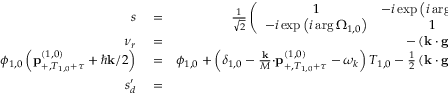Convert formula to latex. <formula><loc_0><loc_0><loc_500><loc_500>\begin{array} { r l r } { s } & = } & { \frac { 1 } { \sqrt { 2 } } \left ( \begin{array} { c c } { 1 } & { - i \exp \left ( i \arg \Omega _ { 1 , 0 } \right ) } \\ { - i \exp \left ( i \arg \Omega _ { 1 , 0 } \right ) } & { 1 } \end{array} \right ) , } \\ { \nu _ { r } } & = } & { - \left ( k \cdot g - \alpha \right ) T _ { 1 , 0 } , } \\ { \phi _ { 1 , 0 } \left ( p _ { + , T _ { 1 , 0 } + \tau } ^ { \left ( 1 , 0 \right ) } + \hbar { k } / 2 \right ) } & = } & { \phi _ { 1 , 0 } + \left ( \delta _ { 1 , 0 } - \frac { k } { M } \cdot p _ { + , T _ { 1 , 0 } + \tau } ^ { \left ( 1 , 0 \right ) } - \omega _ { k } \right ) T _ { 1 , 0 } - \frac { 1 } { 2 } \left ( k \cdot g - \alpha \right ) T _ { 1 , 0 } ^ { 2 } , } \\ { s _ { d } ^ { \prime } } & = } & { \frac { i \sqrt { 2 } } { \pi } , } \end{array}</formula> 